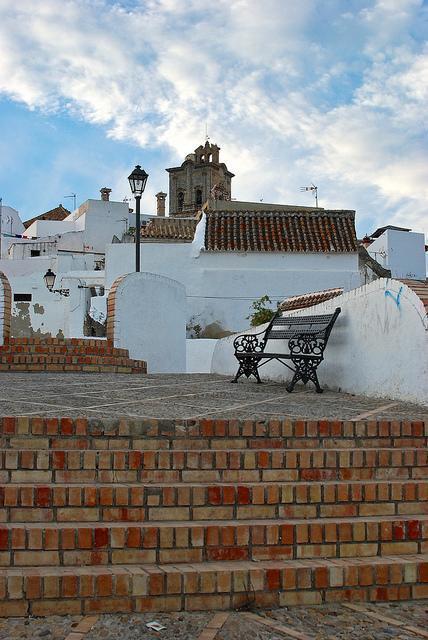How many steps lead up to the statue?
Give a very brief answer. 5. How many layers does this cake have?
Give a very brief answer. 0. 